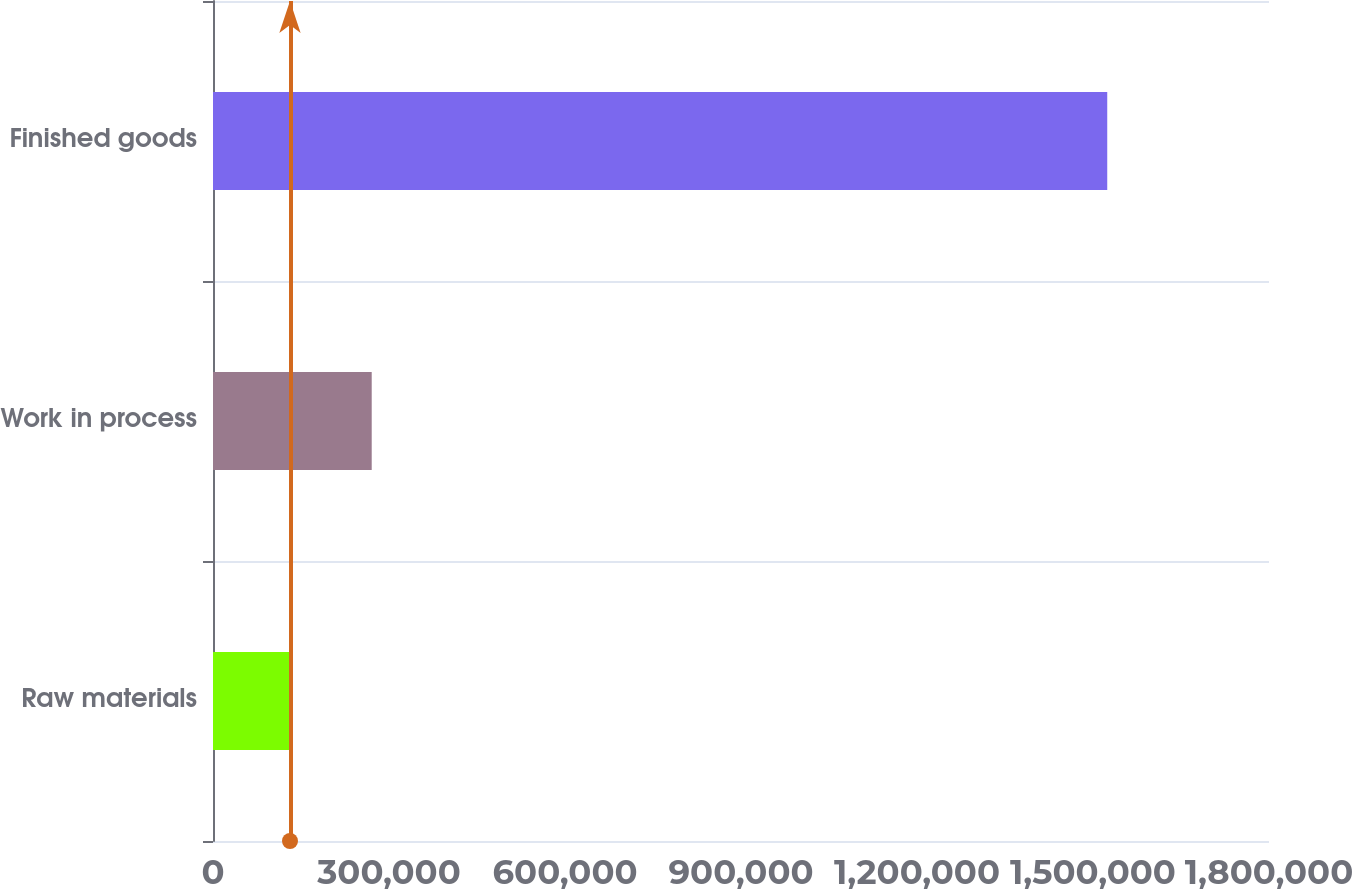Convert chart to OTSL. <chart><loc_0><loc_0><loc_500><loc_500><bar_chart><fcel>Raw materials<fcel>Work in process<fcel>Finished goods<nl><fcel>131228<fcel>270532<fcel>1.52427e+06<nl></chart> 